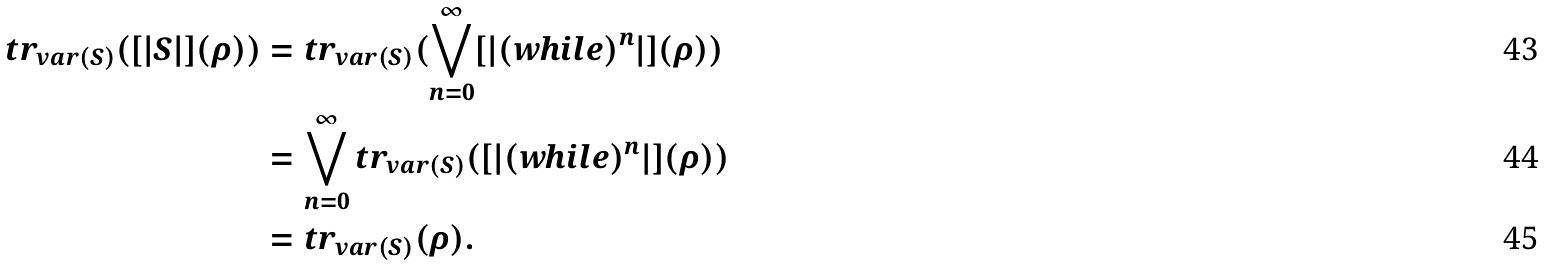Convert formula to latex. <formula><loc_0><loc_0><loc_500><loc_500>t r _ { v a r ( S ) } ( [ | S | ] ( \rho ) ) & = t r _ { v a r ( S ) } ( \bigvee _ { n = 0 } ^ { \infty } [ | ( w h i l e ) ^ { n } | ] ( \rho ) ) \\ & = \bigvee _ { n = 0 } ^ { \infty } t r _ { v a r ( S ) } ( [ | ( w h i l e ) ^ { n } | ] ( \rho ) ) \\ & = t r _ { v a r ( S ) } ( \rho ) .</formula> 